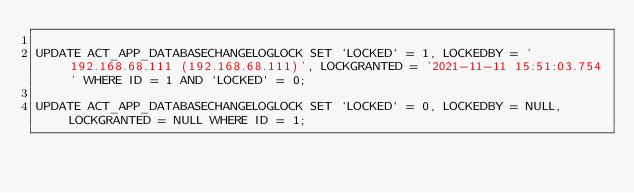Convert code to text. <code><loc_0><loc_0><loc_500><loc_500><_SQL_>
UPDATE ACT_APP_DATABASECHANGELOGLOCK SET `LOCKED` = 1, LOCKEDBY = '192.168.68.111 (192.168.68.111)', LOCKGRANTED = '2021-11-11 15:51:03.754' WHERE ID = 1 AND `LOCKED` = 0;

UPDATE ACT_APP_DATABASECHANGELOGLOCK SET `LOCKED` = 0, LOCKEDBY = NULL, LOCKGRANTED = NULL WHERE ID = 1;

</code> 